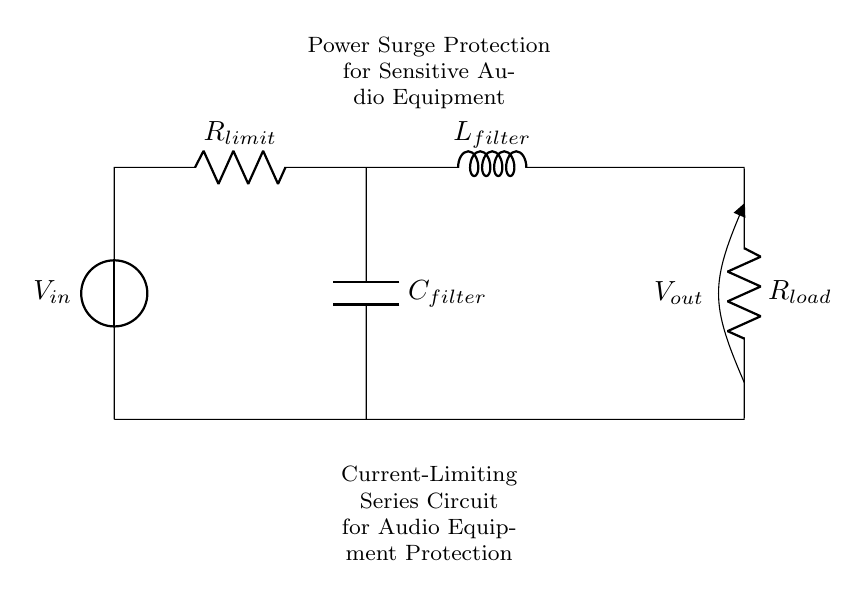What is the purpose of R limit in this circuit? R limit is used to limit the current flowing into the sensitive audio equipment, protecting it from potential damage due to power surges.
Answer: Limit current What type of circuit is represented here? The circuit is a series circuit since all components are connected in a single path, so the same current flows through each component.
Answer: Series circuit What component is used for filtering in this circuit? The component used for filtering is the inductor labeled L filter, which smooths out current variations that could affect audio quality.
Answer: Inductor How many resistors are in this circuit? There are two resistors in this circuit: R limit and R load, each serving a different function within the protection mechanism.
Answer: Two What will happen if the voltage exceeds the circuit's design specifications? If the voltage exceeds specifications, the R limit will restrict excess current, but sustained overload may still lead to equipment failure if protection is inadequate.
Answer: Potential damage What is the function of C filter in this circuit? C filter functions to store charge and smooth out voltage fluctuations from the power supply, ensuring stable operation of the audio equipment.
Answer: Smooth voltage What does V out represent in this circuit? V out represents the output voltage that is supplied to the audio equipment after passing through the current-limiting and filtering components for protection.
Answer: Output voltage 